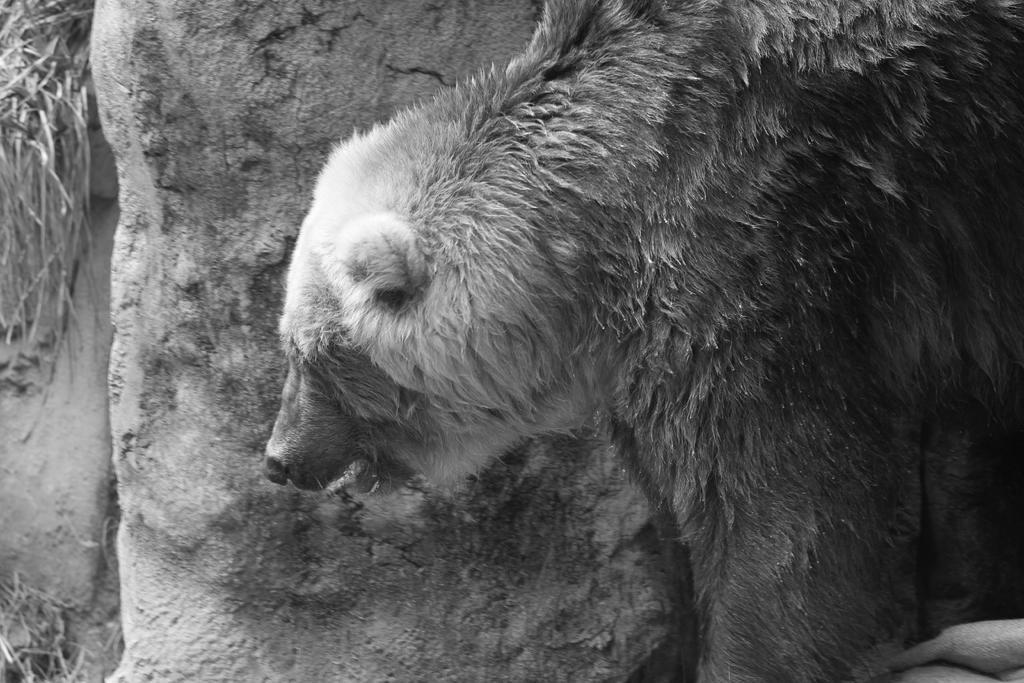Can you describe this image briefly? This is a black and white image. In this image we can see a bear. 